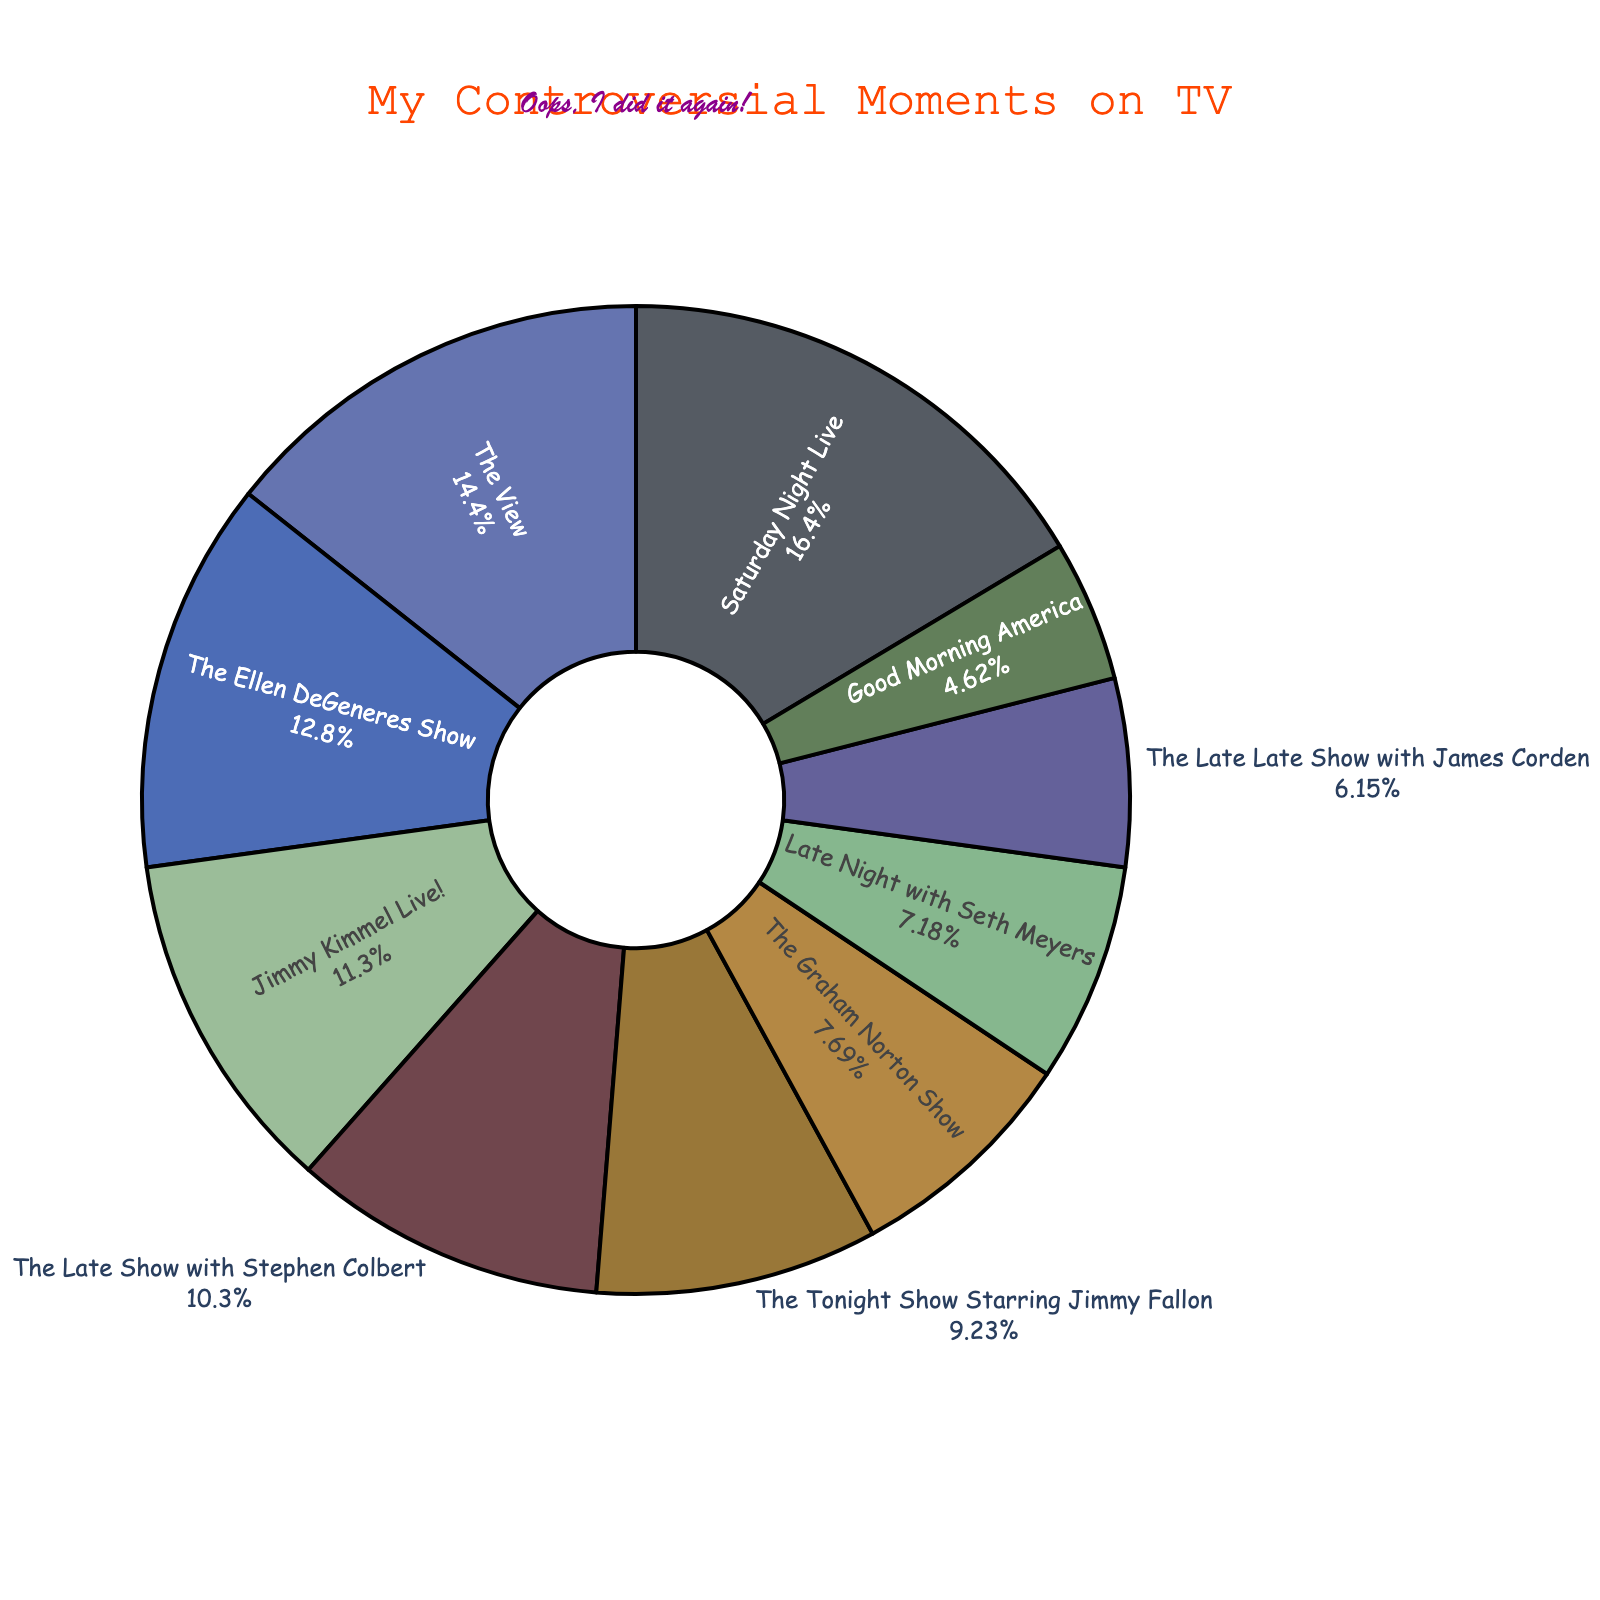What percentage of my controversial moments happened on Saturday Night Live? Look at the segment for "Saturday Night Live", which shows both the count of controversial moments (32) and the percentage. From the pie chart, we see that the corresponding percentage is provided.
Answer: Percentage shown in the figure Which show had more controversial moments, The Ellen DeGeneres Show or The Tonight Show Starring Jimmy Fallon? Compare the values for both shows. The Ellen DeGeneres Show had 25 controversial moments, while The Tonight Show Starring Jimmy Fallon had 18.
Answer: The Ellen DeGeneres Show Are there more controversial moments on The Late Show with Stephen Colbert or Good Morning America? Compare the segments for both shows. The Late Show with Stephen Colbert had 20 controversial moments, while Good Morning America had 9.
Answer: The Late Show with Stephen Colbert Between my appearances on The View and Jimmy Kimmel Live!, which had a higher percentage of controversial moments? The View has 28 moments and Jimmy Kimmel Live! has 22. The View's percentage is higher as it has more moments comparatively to the total.
Answer: The View Which shows have fewer than 15 controversial moments? Subtract the ones with values higher than 15 from the total. From the pie chart, "The Graham Norton Show" (15), "The Late Late Show with James Corden" (12), "Good Morning America" (9), "Late Night with Seth Meyers" (14) have fewer than 15 moments.
Answer: The Late Late Show with James Corden, Good Morning America, Late Night with Seth Meyers What is the total number of controversial moments across all shows? Add up all the controversial moments for each show: 32 + 18 + 25 + 15 + 22 + 12 + 9 + 28 + 14 + 20 = 195.
Answer: 195 What is the difference in the number of controversial moments between The View and Late Night with Seth Meyers? The View has 28 moments and Late Night with Seth Meyers has 14. The difference is 28 - 14.
Answer: 14 How does the number of controversial moments on The Tonight Show Starring Jimmy Fallon compare to Jimmy Kimmel Live!? The Tonight Show Starring Jimmy Fallon has 18 moments, while Jimmy Kimmel Live! has 22. Compare the numbers to see that Jimmy Kimmel Live! has more.
Answer: Jimmy Kimmel Live! has more Which show has the smallest segment in the pie chart? Look for the smallest segment visually in the pie chart. Good Morning America has the smallest segment with 9 moments.
Answer: Good Morning America 